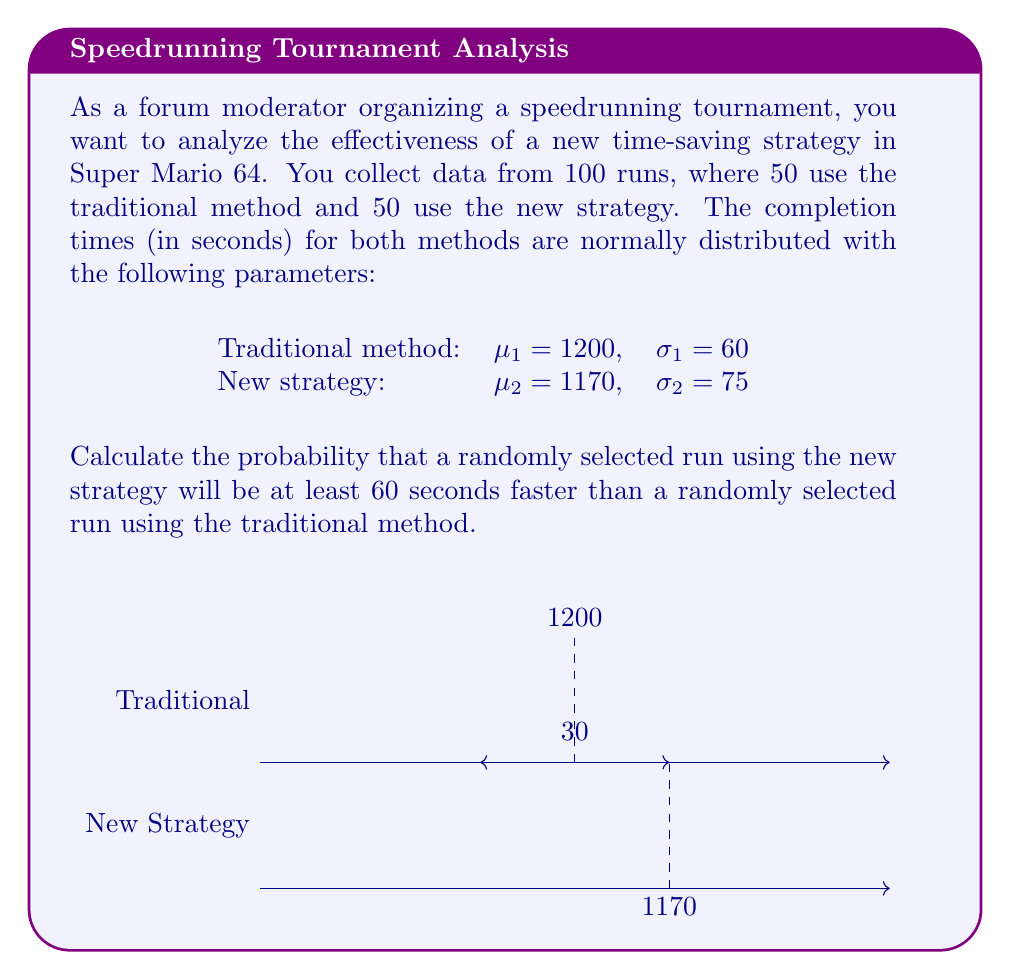Can you solve this math problem? Let's approach this step-by-step:

1) Let $X_1$ be the time for the traditional method and $X_2$ be the time for the new strategy.

2) We need to find $P(X_1 - X_2 \geq 60)$.

3) The difference between two normally distributed variables is also normally distributed. Let $Y = X_1 - X_2$.

4) The mean of Y is:
   $\mu_Y = \mu_1 - \mu_2 = 1200 - 1170 = 30$

5) The variance of Y is the sum of the variances:
   $\sigma_Y^2 = \sigma_1^2 + \sigma_2^2 = 60^2 + 75^2 = 3600 + 5625 = 9225$

6) The standard deviation of Y is:
   $\sigma_Y = \sqrt{9225} = 96.05$

7) Now we need to find $P(Y \geq 60)$.

8) We can standardize this to a Z-score:
   $Z = \frac{60 - \mu_Y}{\sigma_Y} = \frac{60 - 30}{96.05} = 0.3123$

9) We need to find $P(Z \geq 0.3123)$. 

10) Using a standard normal table or calculator, we find:
    $P(Z \geq 0.3123) = 1 - P(Z < 0.3123) = 1 - 0.6226 = 0.3774$

Therefore, the probability that a randomly selected run using the new strategy will be at least 60 seconds faster than a randomly selected run using the traditional method is approximately 0.3774 or 37.74%.
Answer: 0.3774 